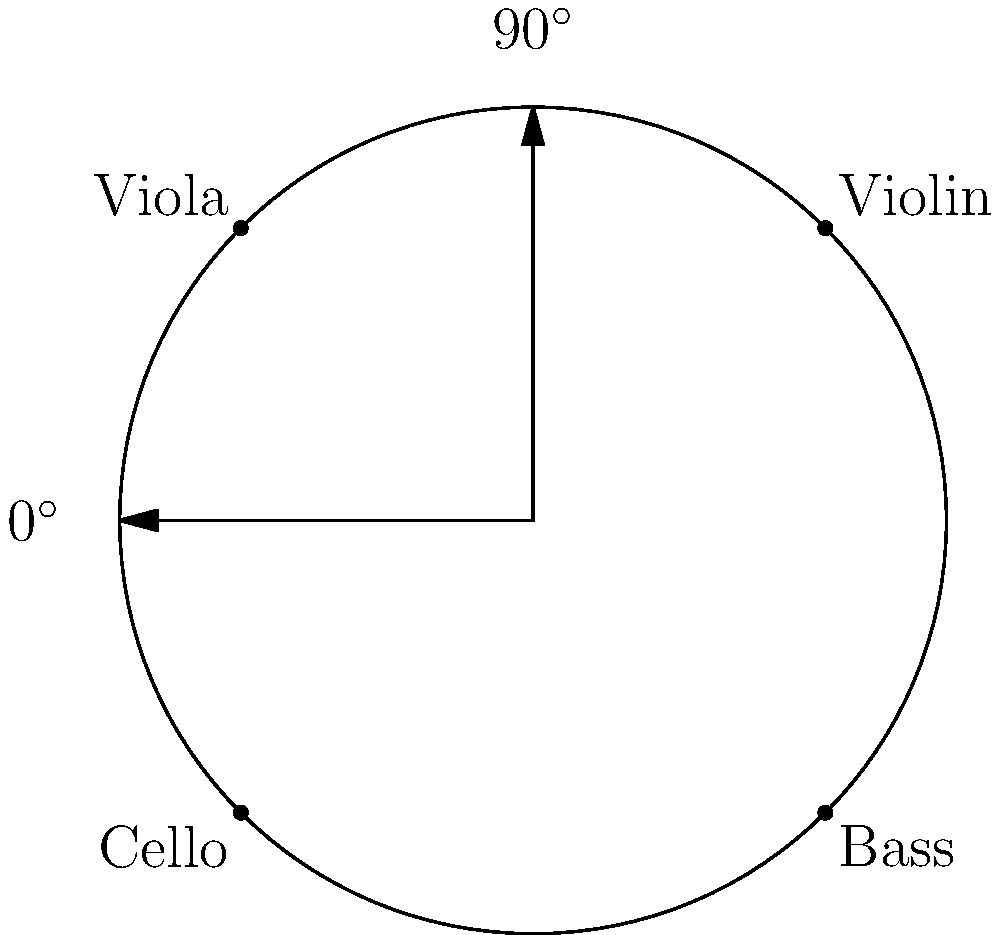As a conductor, you're planning the seating arrangement for a string quartet on a circular stage. Using polar coordinates, where the radius of the stage is 5 meters and the angles are measured counterclockwise from the positive x-axis, determine the polar coordinates $(r, \theta)$ for the cellist if they are positioned at 225°. Express the angle in radians. To solve this problem, let's follow these steps:

1. We know the radius of the stage: $r = 5$ meters.

2. The cellist is positioned at 225°. We need to convert this to radians.

3. To convert degrees to radians, we use the formula:
   $\theta_{radians} = \theta_{degrees} \times \frac{\pi}{180^\circ}$

4. Substituting our value:
   $\theta_{radians} = 225^\circ \times \frac{\pi}{180^\circ} = \frac{5\pi}{4}$ radians

5. Now we have both components of the polar coordinate:
   - Radius $r = 5$ meters
   - Angle $\theta = \frac{5\pi}{4}$ radians

6. The polar coordinate is expressed as an ordered pair $(r, \theta)$.

Therefore, the polar coordinates for the cellist's position are $(5, \frac{5\pi}{4})$.
Answer: $(5, \frac{5\pi}{4})$ 